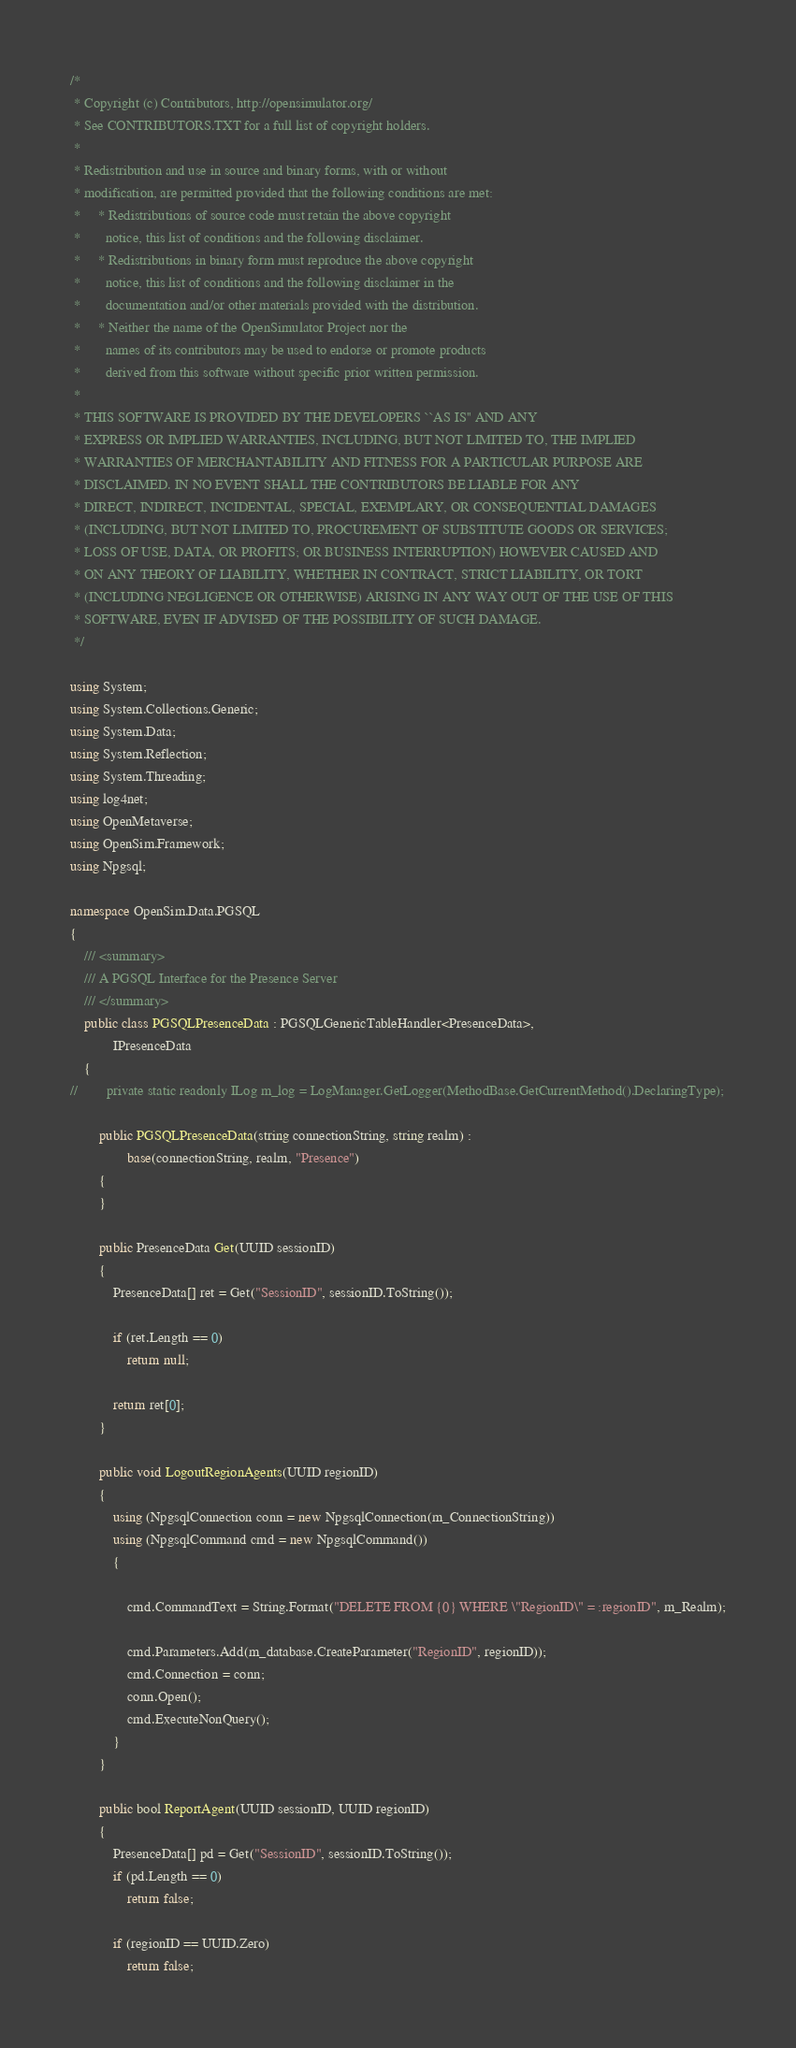<code> <loc_0><loc_0><loc_500><loc_500><_C#_>/*
 * Copyright (c) Contributors, http://opensimulator.org/
 * See CONTRIBUTORS.TXT for a full list of copyright holders.
 *
 * Redistribution and use in source and binary forms, with or without
 * modification, are permitted provided that the following conditions are met:
 *     * Redistributions of source code must retain the above copyright
 *       notice, this list of conditions and the following disclaimer.
 *     * Redistributions in binary form must reproduce the above copyright
 *       notice, this list of conditions and the following disclaimer in the
 *       documentation and/or other materials provided with the distribution.
 *     * Neither the name of the OpenSimulator Project nor the
 *       names of its contributors may be used to endorse or promote products
 *       derived from this software without specific prior written permission.
 *
 * THIS SOFTWARE IS PROVIDED BY THE DEVELOPERS ``AS IS'' AND ANY
 * EXPRESS OR IMPLIED WARRANTIES, INCLUDING, BUT NOT LIMITED TO, THE IMPLIED
 * WARRANTIES OF MERCHANTABILITY AND FITNESS FOR A PARTICULAR PURPOSE ARE
 * DISCLAIMED. IN NO EVENT SHALL THE CONTRIBUTORS BE LIABLE FOR ANY
 * DIRECT, INDIRECT, INCIDENTAL, SPECIAL, EXEMPLARY, OR CONSEQUENTIAL DAMAGES
 * (INCLUDING, BUT NOT LIMITED TO, PROCUREMENT OF SUBSTITUTE GOODS OR SERVICES;
 * LOSS OF USE, DATA, OR PROFITS; OR BUSINESS INTERRUPTION) HOWEVER CAUSED AND
 * ON ANY THEORY OF LIABILITY, WHETHER IN CONTRACT, STRICT LIABILITY, OR TORT
 * (INCLUDING NEGLIGENCE OR OTHERWISE) ARISING IN ANY WAY OUT OF THE USE OF THIS
 * SOFTWARE, EVEN IF ADVISED OF THE POSSIBILITY OF SUCH DAMAGE.
 */

using System;
using System.Collections.Generic;
using System.Data;
using System.Reflection;
using System.Threading;
using log4net;
using OpenMetaverse;
using OpenSim.Framework;
using Npgsql;

namespace OpenSim.Data.PGSQL
{
    /// <summary>
    /// A PGSQL Interface for the Presence Server
    /// </summary>
    public class PGSQLPresenceData : PGSQLGenericTableHandler<PresenceData>,
            IPresenceData
    {
//        private static readonly ILog m_log = LogManager.GetLogger(MethodBase.GetCurrentMethod().DeclaringType);

        public PGSQLPresenceData(string connectionString, string realm) :
                base(connectionString, realm, "Presence")
        {
        }

        public PresenceData Get(UUID sessionID)
        {
            PresenceData[] ret = Get("SessionID", sessionID.ToString());

            if (ret.Length == 0)
                return null;

            return ret[0];
        }

        public void LogoutRegionAgents(UUID regionID)
        {
            using (NpgsqlConnection conn = new NpgsqlConnection(m_ConnectionString))
            using (NpgsqlCommand cmd = new NpgsqlCommand())
            {

                cmd.CommandText = String.Format("DELETE FROM {0} WHERE \"RegionID\" = :regionID", m_Realm);

                cmd.Parameters.Add(m_database.CreateParameter("RegionID", regionID));
                cmd.Connection = conn;
                conn.Open();
                cmd.ExecuteNonQuery();
            }
        }

        public bool ReportAgent(UUID sessionID, UUID regionID)
        {
            PresenceData[] pd = Get("SessionID", sessionID.ToString());
            if (pd.Length == 0)
                return false;
                
            if (regionID == UUID.Zero)
                return false;
</code> 